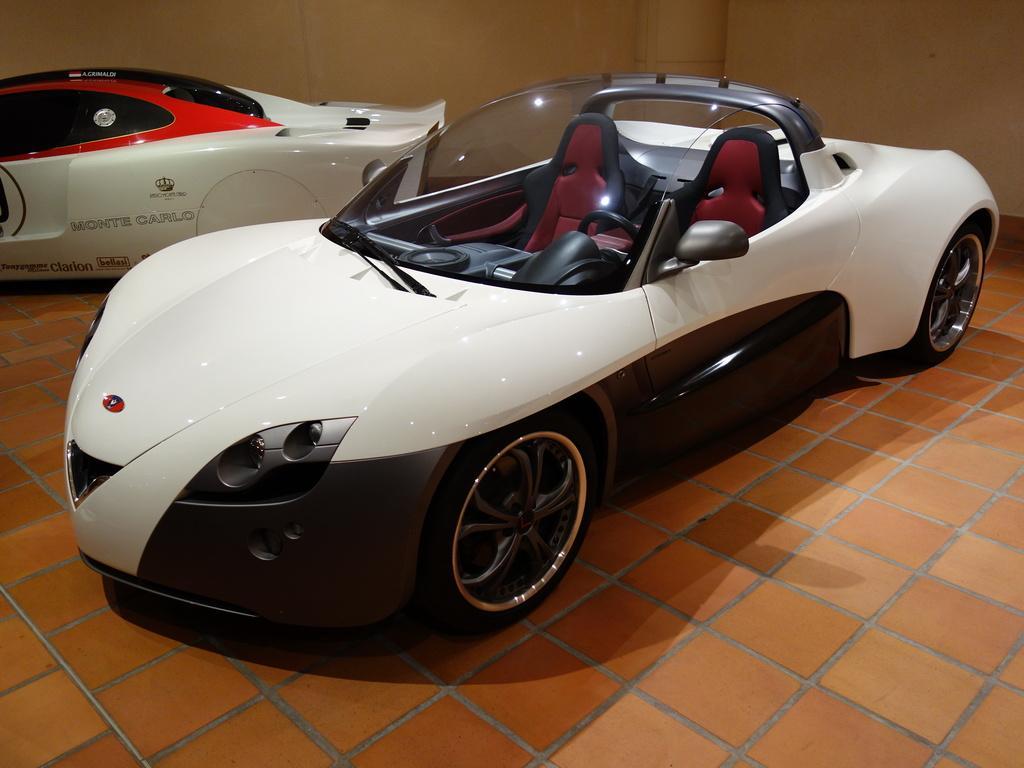How would you summarize this image in a sentence or two? In this image there are vehicles, tile floor and wall. Something is written on the vehicle. 